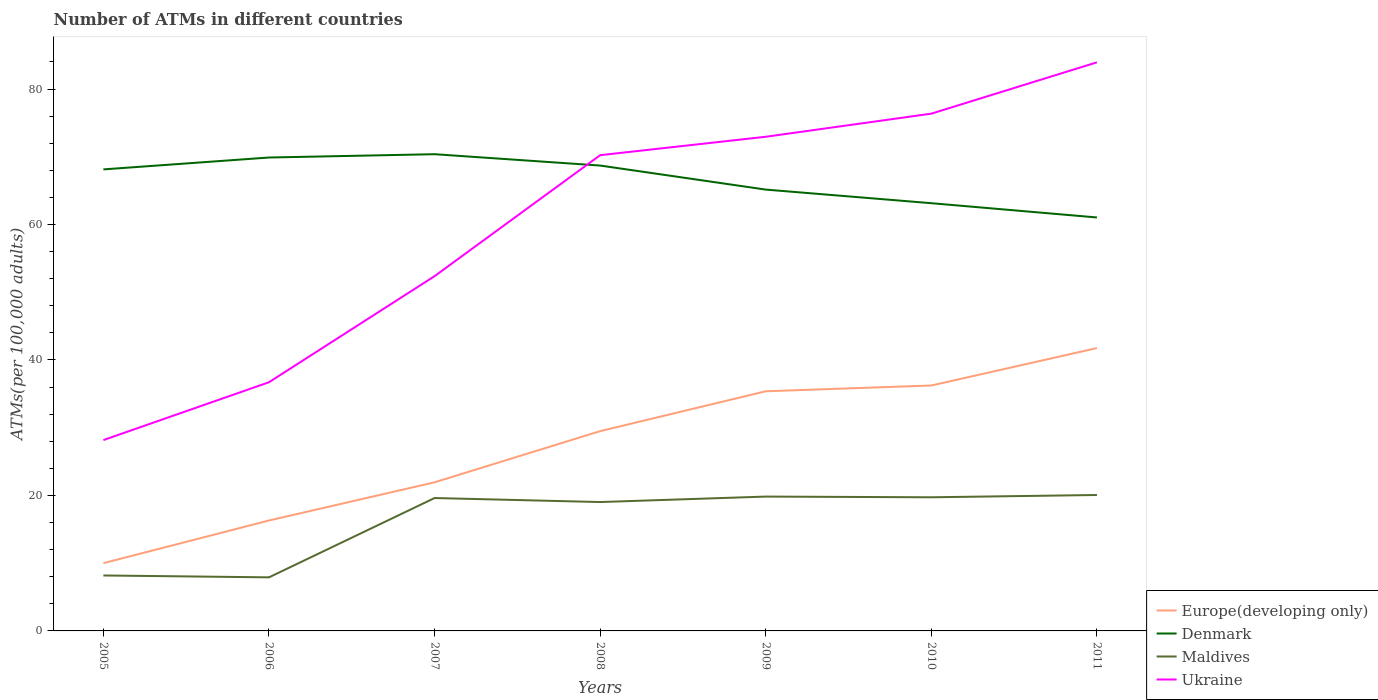Across all years, what is the maximum number of ATMs in Ukraine?
Give a very brief answer. 28.17. In which year was the number of ATMs in Europe(developing only) maximum?
Offer a terse response. 2005. What is the total number of ATMs in Denmark in the graph?
Your response must be concise. -0.57. What is the difference between the highest and the second highest number of ATMs in Denmark?
Offer a very short reply. 9.34. Is the number of ATMs in Ukraine strictly greater than the number of ATMs in Europe(developing only) over the years?
Provide a succinct answer. No. How many years are there in the graph?
Offer a very short reply. 7. Are the values on the major ticks of Y-axis written in scientific E-notation?
Keep it short and to the point. No. Does the graph contain grids?
Provide a succinct answer. No. How many legend labels are there?
Provide a succinct answer. 4. What is the title of the graph?
Your answer should be very brief. Number of ATMs in different countries. What is the label or title of the X-axis?
Keep it short and to the point. Years. What is the label or title of the Y-axis?
Provide a succinct answer. ATMs(per 100,0 adults). What is the ATMs(per 100,000 adults) of Europe(developing only) in 2005?
Ensure brevity in your answer.  10. What is the ATMs(per 100,000 adults) in Denmark in 2005?
Offer a terse response. 68.14. What is the ATMs(per 100,000 adults) of Maldives in 2005?
Offer a very short reply. 8.19. What is the ATMs(per 100,000 adults) of Ukraine in 2005?
Give a very brief answer. 28.17. What is the ATMs(per 100,000 adults) of Europe(developing only) in 2006?
Your answer should be very brief. 16.3. What is the ATMs(per 100,000 adults) in Denmark in 2006?
Offer a terse response. 69.89. What is the ATMs(per 100,000 adults) of Maldives in 2006?
Your response must be concise. 7.91. What is the ATMs(per 100,000 adults) of Ukraine in 2006?
Offer a terse response. 36.72. What is the ATMs(per 100,000 adults) in Europe(developing only) in 2007?
Provide a succinct answer. 21.94. What is the ATMs(per 100,000 adults) of Denmark in 2007?
Your response must be concise. 70.38. What is the ATMs(per 100,000 adults) in Maldives in 2007?
Make the answer very short. 19.62. What is the ATMs(per 100,000 adults) of Ukraine in 2007?
Ensure brevity in your answer.  52.38. What is the ATMs(per 100,000 adults) in Europe(developing only) in 2008?
Provide a succinct answer. 29.5. What is the ATMs(per 100,000 adults) of Denmark in 2008?
Offer a terse response. 68.71. What is the ATMs(per 100,000 adults) of Maldives in 2008?
Keep it short and to the point. 19.03. What is the ATMs(per 100,000 adults) in Ukraine in 2008?
Keep it short and to the point. 70.24. What is the ATMs(per 100,000 adults) of Europe(developing only) in 2009?
Make the answer very short. 35.38. What is the ATMs(per 100,000 adults) of Denmark in 2009?
Keep it short and to the point. 65.16. What is the ATMs(per 100,000 adults) of Maldives in 2009?
Your response must be concise. 19.83. What is the ATMs(per 100,000 adults) of Ukraine in 2009?
Ensure brevity in your answer.  72.96. What is the ATMs(per 100,000 adults) in Europe(developing only) in 2010?
Provide a short and direct response. 36.23. What is the ATMs(per 100,000 adults) of Denmark in 2010?
Your answer should be compact. 63.15. What is the ATMs(per 100,000 adults) of Maldives in 2010?
Provide a succinct answer. 19.73. What is the ATMs(per 100,000 adults) in Ukraine in 2010?
Provide a short and direct response. 76.37. What is the ATMs(per 100,000 adults) of Europe(developing only) in 2011?
Offer a very short reply. 41.76. What is the ATMs(per 100,000 adults) in Denmark in 2011?
Ensure brevity in your answer.  61.04. What is the ATMs(per 100,000 adults) in Maldives in 2011?
Make the answer very short. 20.07. What is the ATMs(per 100,000 adults) in Ukraine in 2011?
Give a very brief answer. 83.95. Across all years, what is the maximum ATMs(per 100,000 adults) of Europe(developing only)?
Offer a very short reply. 41.76. Across all years, what is the maximum ATMs(per 100,000 adults) of Denmark?
Provide a short and direct response. 70.38. Across all years, what is the maximum ATMs(per 100,000 adults) in Maldives?
Provide a succinct answer. 20.07. Across all years, what is the maximum ATMs(per 100,000 adults) in Ukraine?
Ensure brevity in your answer.  83.95. Across all years, what is the minimum ATMs(per 100,000 adults) of Europe(developing only)?
Make the answer very short. 10. Across all years, what is the minimum ATMs(per 100,000 adults) of Denmark?
Make the answer very short. 61.04. Across all years, what is the minimum ATMs(per 100,000 adults) of Maldives?
Make the answer very short. 7.91. Across all years, what is the minimum ATMs(per 100,000 adults) of Ukraine?
Make the answer very short. 28.17. What is the total ATMs(per 100,000 adults) of Europe(developing only) in the graph?
Your answer should be compact. 191.12. What is the total ATMs(per 100,000 adults) in Denmark in the graph?
Your answer should be very brief. 466.47. What is the total ATMs(per 100,000 adults) of Maldives in the graph?
Ensure brevity in your answer.  114.38. What is the total ATMs(per 100,000 adults) in Ukraine in the graph?
Keep it short and to the point. 420.78. What is the difference between the ATMs(per 100,000 adults) of Europe(developing only) in 2005 and that in 2006?
Ensure brevity in your answer.  -6.3. What is the difference between the ATMs(per 100,000 adults) of Denmark in 2005 and that in 2006?
Your answer should be compact. -1.75. What is the difference between the ATMs(per 100,000 adults) in Maldives in 2005 and that in 2006?
Your answer should be very brief. 0.28. What is the difference between the ATMs(per 100,000 adults) in Ukraine in 2005 and that in 2006?
Give a very brief answer. -8.54. What is the difference between the ATMs(per 100,000 adults) in Europe(developing only) in 2005 and that in 2007?
Provide a short and direct response. -11.94. What is the difference between the ATMs(per 100,000 adults) in Denmark in 2005 and that in 2007?
Ensure brevity in your answer.  -2.24. What is the difference between the ATMs(per 100,000 adults) of Maldives in 2005 and that in 2007?
Offer a very short reply. -11.43. What is the difference between the ATMs(per 100,000 adults) in Ukraine in 2005 and that in 2007?
Keep it short and to the point. -24.2. What is the difference between the ATMs(per 100,000 adults) of Europe(developing only) in 2005 and that in 2008?
Your answer should be very brief. -19.49. What is the difference between the ATMs(per 100,000 adults) of Denmark in 2005 and that in 2008?
Your answer should be compact. -0.57. What is the difference between the ATMs(per 100,000 adults) in Maldives in 2005 and that in 2008?
Provide a succinct answer. -10.84. What is the difference between the ATMs(per 100,000 adults) in Ukraine in 2005 and that in 2008?
Offer a very short reply. -42.06. What is the difference between the ATMs(per 100,000 adults) of Europe(developing only) in 2005 and that in 2009?
Ensure brevity in your answer.  -25.38. What is the difference between the ATMs(per 100,000 adults) of Denmark in 2005 and that in 2009?
Offer a terse response. 2.98. What is the difference between the ATMs(per 100,000 adults) of Maldives in 2005 and that in 2009?
Your answer should be compact. -11.65. What is the difference between the ATMs(per 100,000 adults) in Ukraine in 2005 and that in 2009?
Provide a succinct answer. -44.78. What is the difference between the ATMs(per 100,000 adults) in Europe(developing only) in 2005 and that in 2010?
Offer a terse response. -26.23. What is the difference between the ATMs(per 100,000 adults) in Denmark in 2005 and that in 2010?
Your answer should be very brief. 4.99. What is the difference between the ATMs(per 100,000 adults) of Maldives in 2005 and that in 2010?
Your response must be concise. -11.54. What is the difference between the ATMs(per 100,000 adults) of Ukraine in 2005 and that in 2010?
Your answer should be very brief. -48.19. What is the difference between the ATMs(per 100,000 adults) in Europe(developing only) in 2005 and that in 2011?
Offer a terse response. -31.76. What is the difference between the ATMs(per 100,000 adults) of Denmark in 2005 and that in 2011?
Provide a short and direct response. 7.1. What is the difference between the ATMs(per 100,000 adults) in Maldives in 2005 and that in 2011?
Provide a succinct answer. -11.88. What is the difference between the ATMs(per 100,000 adults) of Ukraine in 2005 and that in 2011?
Ensure brevity in your answer.  -55.77. What is the difference between the ATMs(per 100,000 adults) of Europe(developing only) in 2006 and that in 2007?
Keep it short and to the point. -5.64. What is the difference between the ATMs(per 100,000 adults) in Denmark in 2006 and that in 2007?
Provide a succinct answer. -0.49. What is the difference between the ATMs(per 100,000 adults) of Maldives in 2006 and that in 2007?
Your answer should be compact. -11.71. What is the difference between the ATMs(per 100,000 adults) of Ukraine in 2006 and that in 2007?
Keep it short and to the point. -15.66. What is the difference between the ATMs(per 100,000 adults) of Europe(developing only) in 2006 and that in 2008?
Provide a short and direct response. -13.19. What is the difference between the ATMs(per 100,000 adults) of Denmark in 2006 and that in 2008?
Make the answer very short. 1.19. What is the difference between the ATMs(per 100,000 adults) of Maldives in 2006 and that in 2008?
Your answer should be very brief. -11.12. What is the difference between the ATMs(per 100,000 adults) of Ukraine in 2006 and that in 2008?
Your response must be concise. -33.52. What is the difference between the ATMs(per 100,000 adults) of Europe(developing only) in 2006 and that in 2009?
Ensure brevity in your answer.  -19.08. What is the difference between the ATMs(per 100,000 adults) in Denmark in 2006 and that in 2009?
Your answer should be compact. 4.74. What is the difference between the ATMs(per 100,000 adults) in Maldives in 2006 and that in 2009?
Give a very brief answer. -11.93. What is the difference between the ATMs(per 100,000 adults) of Ukraine in 2006 and that in 2009?
Provide a short and direct response. -36.24. What is the difference between the ATMs(per 100,000 adults) in Europe(developing only) in 2006 and that in 2010?
Provide a short and direct response. -19.93. What is the difference between the ATMs(per 100,000 adults) of Denmark in 2006 and that in 2010?
Give a very brief answer. 6.74. What is the difference between the ATMs(per 100,000 adults) of Maldives in 2006 and that in 2010?
Offer a terse response. -11.82. What is the difference between the ATMs(per 100,000 adults) in Ukraine in 2006 and that in 2010?
Provide a short and direct response. -39.65. What is the difference between the ATMs(per 100,000 adults) of Europe(developing only) in 2006 and that in 2011?
Ensure brevity in your answer.  -25.45. What is the difference between the ATMs(per 100,000 adults) of Denmark in 2006 and that in 2011?
Your answer should be very brief. 8.85. What is the difference between the ATMs(per 100,000 adults) of Maldives in 2006 and that in 2011?
Provide a succinct answer. -12.16. What is the difference between the ATMs(per 100,000 adults) of Ukraine in 2006 and that in 2011?
Your answer should be compact. -47.23. What is the difference between the ATMs(per 100,000 adults) of Europe(developing only) in 2007 and that in 2008?
Offer a very short reply. -7.55. What is the difference between the ATMs(per 100,000 adults) in Denmark in 2007 and that in 2008?
Offer a terse response. 1.68. What is the difference between the ATMs(per 100,000 adults) of Maldives in 2007 and that in 2008?
Make the answer very short. 0.59. What is the difference between the ATMs(per 100,000 adults) in Ukraine in 2007 and that in 2008?
Give a very brief answer. -17.86. What is the difference between the ATMs(per 100,000 adults) in Europe(developing only) in 2007 and that in 2009?
Provide a succinct answer. -13.44. What is the difference between the ATMs(per 100,000 adults) of Denmark in 2007 and that in 2009?
Your response must be concise. 5.23. What is the difference between the ATMs(per 100,000 adults) in Maldives in 2007 and that in 2009?
Your answer should be very brief. -0.22. What is the difference between the ATMs(per 100,000 adults) in Ukraine in 2007 and that in 2009?
Offer a terse response. -20.58. What is the difference between the ATMs(per 100,000 adults) in Europe(developing only) in 2007 and that in 2010?
Your response must be concise. -14.29. What is the difference between the ATMs(per 100,000 adults) of Denmark in 2007 and that in 2010?
Provide a short and direct response. 7.23. What is the difference between the ATMs(per 100,000 adults) of Maldives in 2007 and that in 2010?
Your response must be concise. -0.11. What is the difference between the ATMs(per 100,000 adults) in Ukraine in 2007 and that in 2010?
Your answer should be compact. -23.99. What is the difference between the ATMs(per 100,000 adults) of Europe(developing only) in 2007 and that in 2011?
Your response must be concise. -19.82. What is the difference between the ATMs(per 100,000 adults) of Denmark in 2007 and that in 2011?
Offer a terse response. 9.34. What is the difference between the ATMs(per 100,000 adults) in Maldives in 2007 and that in 2011?
Make the answer very short. -0.45. What is the difference between the ATMs(per 100,000 adults) in Ukraine in 2007 and that in 2011?
Your response must be concise. -31.57. What is the difference between the ATMs(per 100,000 adults) in Europe(developing only) in 2008 and that in 2009?
Offer a terse response. -5.88. What is the difference between the ATMs(per 100,000 adults) of Denmark in 2008 and that in 2009?
Give a very brief answer. 3.55. What is the difference between the ATMs(per 100,000 adults) of Maldives in 2008 and that in 2009?
Provide a succinct answer. -0.81. What is the difference between the ATMs(per 100,000 adults) in Ukraine in 2008 and that in 2009?
Provide a short and direct response. -2.72. What is the difference between the ATMs(per 100,000 adults) of Europe(developing only) in 2008 and that in 2010?
Provide a short and direct response. -6.74. What is the difference between the ATMs(per 100,000 adults) of Denmark in 2008 and that in 2010?
Your answer should be compact. 5.56. What is the difference between the ATMs(per 100,000 adults) in Maldives in 2008 and that in 2010?
Offer a terse response. -0.7. What is the difference between the ATMs(per 100,000 adults) in Ukraine in 2008 and that in 2010?
Offer a very short reply. -6.13. What is the difference between the ATMs(per 100,000 adults) in Europe(developing only) in 2008 and that in 2011?
Provide a short and direct response. -12.26. What is the difference between the ATMs(per 100,000 adults) in Denmark in 2008 and that in 2011?
Make the answer very short. 7.66. What is the difference between the ATMs(per 100,000 adults) of Maldives in 2008 and that in 2011?
Provide a short and direct response. -1.04. What is the difference between the ATMs(per 100,000 adults) of Ukraine in 2008 and that in 2011?
Keep it short and to the point. -13.71. What is the difference between the ATMs(per 100,000 adults) in Europe(developing only) in 2009 and that in 2010?
Give a very brief answer. -0.85. What is the difference between the ATMs(per 100,000 adults) in Denmark in 2009 and that in 2010?
Offer a very short reply. 2.01. What is the difference between the ATMs(per 100,000 adults) in Maldives in 2009 and that in 2010?
Your response must be concise. 0.1. What is the difference between the ATMs(per 100,000 adults) of Ukraine in 2009 and that in 2010?
Ensure brevity in your answer.  -3.41. What is the difference between the ATMs(per 100,000 adults) of Europe(developing only) in 2009 and that in 2011?
Ensure brevity in your answer.  -6.38. What is the difference between the ATMs(per 100,000 adults) of Denmark in 2009 and that in 2011?
Keep it short and to the point. 4.11. What is the difference between the ATMs(per 100,000 adults) of Maldives in 2009 and that in 2011?
Ensure brevity in your answer.  -0.23. What is the difference between the ATMs(per 100,000 adults) of Ukraine in 2009 and that in 2011?
Your answer should be compact. -10.99. What is the difference between the ATMs(per 100,000 adults) of Europe(developing only) in 2010 and that in 2011?
Provide a succinct answer. -5.52. What is the difference between the ATMs(per 100,000 adults) of Denmark in 2010 and that in 2011?
Offer a terse response. 2.11. What is the difference between the ATMs(per 100,000 adults) of Maldives in 2010 and that in 2011?
Provide a succinct answer. -0.34. What is the difference between the ATMs(per 100,000 adults) in Ukraine in 2010 and that in 2011?
Ensure brevity in your answer.  -7.58. What is the difference between the ATMs(per 100,000 adults) in Europe(developing only) in 2005 and the ATMs(per 100,000 adults) in Denmark in 2006?
Give a very brief answer. -59.89. What is the difference between the ATMs(per 100,000 adults) of Europe(developing only) in 2005 and the ATMs(per 100,000 adults) of Maldives in 2006?
Give a very brief answer. 2.09. What is the difference between the ATMs(per 100,000 adults) in Europe(developing only) in 2005 and the ATMs(per 100,000 adults) in Ukraine in 2006?
Give a very brief answer. -26.71. What is the difference between the ATMs(per 100,000 adults) of Denmark in 2005 and the ATMs(per 100,000 adults) of Maldives in 2006?
Your answer should be very brief. 60.23. What is the difference between the ATMs(per 100,000 adults) in Denmark in 2005 and the ATMs(per 100,000 adults) in Ukraine in 2006?
Ensure brevity in your answer.  31.42. What is the difference between the ATMs(per 100,000 adults) of Maldives in 2005 and the ATMs(per 100,000 adults) of Ukraine in 2006?
Make the answer very short. -28.53. What is the difference between the ATMs(per 100,000 adults) of Europe(developing only) in 2005 and the ATMs(per 100,000 adults) of Denmark in 2007?
Give a very brief answer. -60.38. What is the difference between the ATMs(per 100,000 adults) in Europe(developing only) in 2005 and the ATMs(per 100,000 adults) in Maldives in 2007?
Keep it short and to the point. -9.62. What is the difference between the ATMs(per 100,000 adults) of Europe(developing only) in 2005 and the ATMs(per 100,000 adults) of Ukraine in 2007?
Give a very brief answer. -42.38. What is the difference between the ATMs(per 100,000 adults) of Denmark in 2005 and the ATMs(per 100,000 adults) of Maldives in 2007?
Your answer should be very brief. 48.52. What is the difference between the ATMs(per 100,000 adults) in Denmark in 2005 and the ATMs(per 100,000 adults) in Ukraine in 2007?
Your answer should be compact. 15.76. What is the difference between the ATMs(per 100,000 adults) in Maldives in 2005 and the ATMs(per 100,000 adults) in Ukraine in 2007?
Your answer should be compact. -44.19. What is the difference between the ATMs(per 100,000 adults) in Europe(developing only) in 2005 and the ATMs(per 100,000 adults) in Denmark in 2008?
Keep it short and to the point. -58.7. What is the difference between the ATMs(per 100,000 adults) of Europe(developing only) in 2005 and the ATMs(per 100,000 adults) of Maldives in 2008?
Your answer should be very brief. -9.03. What is the difference between the ATMs(per 100,000 adults) of Europe(developing only) in 2005 and the ATMs(per 100,000 adults) of Ukraine in 2008?
Provide a short and direct response. -60.24. What is the difference between the ATMs(per 100,000 adults) in Denmark in 2005 and the ATMs(per 100,000 adults) in Maldives in 2008?
Provide a short and direct response. 49.11. What is the difference between the ATMs(per 100,000 adults) of Denmark in 2005 and the ATMs(per 100,000 adults) of Ukraine in 2008?
Your answer should be compact. -2.1. What is the difference between the ATMs(per 100,000 adults) in Maldives in 2005 and the ATMs(per 100,000 adults) in Ukraine in 2008?
Provide a short and direct response. -62.05. What is the difference between the ATMs(per 100,000 adults) in Europe(developing only) in 2005 and the ATMs(per 100,000 adults) in Denmark in 2009?
Your answer should be very brief. -55.15. What is the difference between the ATMs(per 100,000 adults) of Europe(developing only) in 2005 and the ATMs(per 100,000 adults) of Maldives in 2009?
Your response must be concise. -9.83. What is the difference between the ATMs(per 100,000 adults) in Europe(developing only) in 2005 and the ATMs(per 100,000 adults) in Ukraine in 2009?
Make the answer very short. -62.95. What is the difference between the ATMs(per 100,000 adults) in Denmark in 2005 and the ATMs(per 100,000 adults) in Maldives in 2009?
Provide a short and direct response. 48.31. What is the difference between the ATMs(per 100,000 adults) in Denmark in 2005 and the ATMs(per 100,000 adults) in Ukraine in 2009?
Your answer should be compact. -4.82. What is the difference between the ATMs(per 100,000 adults) of Maldives in 2005 and the ATMs(per 100,000 adults) of Ukraine in 2009?
Make the answer very short. -64.77. What is the difference between the ATMs(per 100,000 adults) in Europe(developing only) in 2005 and the ATMs(per 100,000 adults) in Denmark in 2010?
Your response must be concise. -53.15. What is the difference between the ATMs(per 100,000 adults) in Europe(developing only) in 2005 and the ATMs(per 100,000 adults) in Maldives in 2010?
Make the answer very short. -9.73. What is the difference between the ATMs(per 100,000 adults) of Europe(developing only) in 2005 and the ATMs(per 100,000 adults) of Ukraine in 2010?
Provide a short and direct response. -66.37. What is the difference between the ATMs(per 100,000 adults) of Denmark in 2005 and the ATMs(per 100,000 adults) of Maldives in 2010?
Give a very brief answer. 48.41. What is the difference between the ATMs(per 100,000 adults) of Denmark in 2005 and the ATMs(per 100,000 adults) of Ukraine in 2010?
Make the answer very short. -8.23. What is the difference between the ATMs(per 100,000 adults) of Maldives in 2005 and the ATMs(per 100,000 adults) of Ukraine in 2010?
Give a very brief answer. -68.18. What is the difference between the ATMs(per 100,000 adults) in Europe(developing only) in 2005 and the ATMs(per 100,000 adults) in Denmark in 2011?
Your answer should be very brief. -51.04. What is the difference between the ATMs(per 100,000 adults) in Europe(developing only) in 2005 and the ATMs(per 100,000 adults) in Maldives in 2011?
Ensure brevity in your answer.  -10.07. What is the difference between the ATMs(per 100,000 adults) of Europe(developing only) in 2005 and the ATMs(per 100,000 adults) of Ukraine in 2011?
Make the answer very short. -73.94. What is the difference between the ATMs(per 100,000 adults) in Denmark in 2005 and the ATMs(per 100,000 adults) in Maldives in 2011?
Give a very brief answer. 48.07. What is the difference between the ATMs(per 100,000 adults) in Denmark in 2005 and the ATMs(per 100,000 adults) in Ukraine in 2011?
Provide a succinct answer. -15.81. What is the difference between the ATMs(per 100,000 adults) of Maldives in 2005 and the ATMs(per 100,000 adults) of Ukraine in 2011?
Give a very brief answer. -75.76. What is the difference between the ATMs(per 100,000 adults) in Europe(developing only) in 2006 and the ATMs(per 100,000 adults) in Denmark in 2007?
Provide a short and direct response. -54.08. What is the difference between the ATMs(per 100,000 adults) of Europe(developing only) in 2006 and the ATMs(per 100,000 adults) of Maldives in 2007?
Your response must be concise. -3.31. What is the difference between the ATMs(per 100,000 adults) in Europe(developing only) in 2006 and the ATMs(per 100,000 adults) in Ukraine in 2007?
Offer a terse response. -36.07. What is the difference between the ATMs(per 100,000 adults) of Denmark in 2006 and the ATMs(per 100,000 adults) of Maldives in 2007?
Your response must be concise. 50.27. What is the difference between the ATMs(per 100,000 adults) in Denmark in 2006 and the ATMs(per 100,000 adults) in Ukraine in 2007?
Provide a succinct answer. 17.52. What is the difference between the ATMs(per 100,000 adults) in Maldives in 2006 and the ATMs(per 100,000 adults) in Ukraine in 2007?
Give a very brief answer. -44.47. What is the difference between the ATMs(per 100,000 adults) of Europe(developing only) in 2006 and the ATMs(per 100,000 adults) of Denmark in 2008?
Make the answer very short. -52.4. What is the difference between the ATMs(per 100,000 adults) of Europe(developing only) in 2006 and the ATMs(per 100,000 adults) of Maldives in 2008?
Your answer should be very brief. -2.72. What is the difference between the ATMs(per 100,000 adults) in Europe(developing only) in 2006 and the ATMs(per 100,000 adults) in Ukraine in 2008?
Give a very brief answer. -53.93. What is the difference between the ATMs(per 100,000 adults) in Denmark in 2006 and the ATMs(per 100,000 adults) in Maldives in 2008?
Offer a very short reply. 50.87. What is the difference between the ATMs(per 100,000 adults) of Denmark in 2006 and the ATMs(per 100,000 adults) of Ukraine in 2008?
Provide a succinct answer. -0.34. What is the difference between the ATMs(per 100,000 adults) in Maldives in 2006 and the ATMs(per 100,000 adults) in Ukraine in 2008?
Offer a very short reply. -62.33. What is the difference between the ATMs(per 100,000 adults) in Europe(developing only) in 2006 and the ATMs(per 100,000 adults) in Denmark in 2009?
Offer a terse response. -48.85. What is the difference between the ATMs(per 100,000 adults) of Europe(developing only) in 2006 and the ATMs(per 100,000 adults) of Maldives in 2009?
Provide a succinct answer. -3.53. What is the difference between the ATMs(per 100,000 adults) in Europe(developing only) in 2006 and the ATMs(per 100,000 adults) in Ukraine in 2009?
Provide a succinct answer. -56.65. What is the difference between the ATMs(per 100,000 adults) in Denmark in 2006 and the ATMs(per 100,000 adults) in Maldives in 2009?
Make the answer very short. 50.06. What is the difference between the ATMs(per 100,000 adults) of Denmark in 2006 and the ATMs(per 100,000 adults) of Ukraine in 2009?
Offer a terse response. -3.06. What is the difference between the ATMs(per 100,000 adults) in Maldives in 2006 and the ATMs(per 100,000 adults) in Ukraine in 2009?
Provide a succinct answer. -65.05. What is the difference between the ATMs(per 100,000 adults) in Europe(developing only) in 2006 and the ATMs(per 100,000 adults) in Denmark in 2010?
Provide a short and direct response. -46.84. What is the difference between the ATMs(per 100,000 adults) in Europe(developing only) in 2006 and the ATMs(per 100,000 adults) in Maldives in 2010?
Offer a terse response. -3.43. What is the difference between the ATMs(per 100,000 adults) of Europe(developing only) in 2006 and the ATMs(per 100,000 adults) of Ukraine in 2010?
Provide a succinct answer. -60.06. What is the difference between the ATMs(per 100,000 adults) of Denmark in 2006 and the ATMs(per 100,000 adults) of Maldives in 2010?
Offer a terse response. 50.16. What is the difference between the ATMs(per 100,000 adults) in Denmark in 2006 and the ATMs(per 100,000 adults) in Ukraine in 2010?
Your answer should be compact. -6.48. What is the difference between the ATMs(per 100,000 adults) of Maldives in 2006 and the ATMs(per 100,000 adults) of Ukraine in 2010?
Your answer should be compact. -68.46. What is the difference between the ATMs(per 100,000 adults) of Europe(developing only) in 2006 and the ATMs(per 100,000 adults) of Denmark in 2011?
Ensure brevity in your answer.  -44.74. What is the difference between the ATMs(per 100,000 adults) of Europe(developing only) in 2006 and the ATMs(per 100,000 adults) of Maldives in 2011?
Keep it short and to the point. -3.76. What is the difference between the ATMs(per 100,000 adults) of Europe(developing only) in 2006 and the ATMs(per 100,000 adults) of Ukraine in 2011?
Provide a short and direct response. -67.64. What is the difference between the ATMs(per 100,000 adults) of Denmark in 2006 and the ATMs(per 100,000 adults) of Maldives in 2011?
Provide a succinct answer. 49.82. What is the difference between the ATMs(per 100,000 adults) of Denmark in 2006 and the ATMs(per 100,000 adults) of Ukraine in 2011?
Your response must be concise. -14.05. What is the difference between the ATMs(per 100,000 adults) in Maldives in 2006 and the ATMs(per 100,000 adults) in Ukraine in 2011?
Give a very brief answer. -76.04. What is the difference between the ATMs(per 100,000 adults) in Europe(developing only) in 2007 and the ATMs(per 100,000 adults) in Denmark in 2008?
Provide a succinct answer. -46.76. What is the difference between the ATMs(per 100,000 adults) of Europe(developing only) in 2007 and the ATMs(per 100,000 adults) of Maldives in 2008?
Keep it short and to the point. 2.91. What is the difference between the ATMs(per 100,000 adults) in Europe(developing only) in 2007 and the ATMs(per 100,000 adults) in Ukraine in 2008?
Offer a very short reply. -48.3. What is the difference between the ATMs(per 100,000 adults) of Denmark in 2007 and the ATMs(per 100,000 adults) of Maldives in 2008?
Your answer should be compact. 51.35. What is the difference between the ATMs(per 100,000 adults) in Denmark in 2007 and the ATMs(per 100,000 adults) in Ukraine in 2008?
Make the answer very short. 0.14. What is the difference between the ATMs(per 100,000 adults) in Maldives in 2007 and the ATMs(per 100,000 adults) in Ukraine in 2008?
Your answer should be compact. -50.62. What is the difference between the ATMs(per 100,000 adults) in Europe(developing only) in 2007 and the ATMs(per 100,000 adults) in Denmark in 2009?
Your answer should be very brief. -43.22. What is the difference between the ATMs(per 100,000 adults) of Europe(developing only) in 2007 and the ATMs(per 100,000 adults) of Maldives in 2009?
Your response must be concise. 2.11. What is the difference between the ATMs(per 100,000 adults) in Europe(developing only) in 2007 and the ATMs(per 100,000 adults) in Ukraine in 2009?
Make the answer very short. -51.01. What is the difference between the ATMs(per 100,000 adults) in Denmark in 2007 and the ATMs(per 100,000 adults) in Maldives in 2009?
Offer a terse response. 50.55. What is the difference between the ATMs(per 100,000 adults) in Denmark in 2007 and the ATMs(per 100,000 adults) in Ukraine in 2009?
Ensure brevity in your answer.  -2.57. What is the difference between the ATMs(per 100,000 adults) in Maldives in 2007 and the ATMs(per 100,000 adults) in Ukraine in 2009?
Your answer should be compact. -53.34. What is the difference between the ATMs(per 100,000 adults) in Europe(developing only) in 2007 and the ATMs(per 100,000 adults) in Denmark in 2010?
Offer a terse response. -41.21. What is the difference between the ATMs(per 100,000 adults) in Europe(developing only) in 2007 and the ATMs(per 100,000 adults) in Maldives in 2010?
Your answer should be very brief. 2.21. What is the difference between the ATMs(per 100,000 adults) in Europe(developing only) in 2007 and the ATMs(per 100,000 adults) in Ukraine in 2010?
Your answer should be compact. -54.43. What is the difference between the ATMs(per 100,000 adults) in Denmark in 2007 and the ATMs(per 100,000 adults) in Maldives in 2010?
Your answer should be very brief. 50.65. What is the difference between the ATMs(per 100,000 adults) of Denmark in 2007 and the ATMs(per 100,000 adults) of Ukraine in 2010?
Your answer should be very brief. -5.99. What is the difference between the ATMs(per 100,000 adults) of Maldives in 2007 and the ATMs(per 100,000 adults) of Ukraine in 2010?
Provide a short and direct response. -56.75. What is the difference between the ATMs(per 100,000 adults) of Europe(developing only) in 2007 and the ATMs(per 100,000 adults) of Denmark in 2011?
Give a very brief answer. -39.1. What is the difference between the ATMs(per 100,000 adults) in Europe(developing only) in 2007 and the ATMs(per 100,000 adults) in Maldives in 2011?
Your answer should be very brief. 1.87. What is the difference between the ATMs(per 100,000 adults) in Europe(developing only) in 2007 and the ATMs(per 100,000 adults) in Ukraine in 2011?
Provide a succinct answer. -62. What is the difference between the ATMs(per 100,000 adults) of Denmark in 2007 and the ATMs(per 100,000 adults) of Maldives in 2011?
Offer a very short reply. 50.31. What is the difference between the ATMs(per 100,000 adults) in Denmark in 2007 and the ATMs(per 100,000 adults) in Ukraine in 2011?
Offer a terse response. -13.56. What is the difference between the ATMs(per 100,000 adults) of Maldives in 2007 and the ATMs(per 100,000 adults) of Ukraine in 2011?
Keep it short and to the point. -64.33. What is the difference between the ATMs(per 100,000 adults) in Europe(developing only) in 2008 and the ATMs(per 100,000 adults) in Denmark in 2009?
Provide a succinct answer. -35.66. What is the difference between the ATMs(per 100,000 adults) of Europe(developing only) in 2008 and the ATMs(per 100,000 adults) of Maldives in 2009?
Give a very brief answer. 9.66. What is the difference between the ATMs(per 100,000 adults) in Europe(developing only) in 2008 and the ATMs(per 100,000 adults) in Ukraine in 2009?
Offer a terse response. -43.46. What is the difference between the ATMs(per 100,000 adults) in Denmark in 2008 and the ATMs(per 100,000 adults) in Maldives in 2009?
Ensure brevity in your answer.  48.87. What is the difference between the ATMs(per 100,000 adults) of Denmark in 2008 and the ATMs(per 100,000 adults) of Ukraine in 2009?
Provide a short and direct response. -4.25. What is the difference between the ATMs(per 100,000 adults) in Maldives in 2008 and the ATMs(per 100,000 adults) in Ukraine in 2009?
Offer a terse response. -53.93. What is the difference between the ATMs(per 100,000 adults) in Europe(developing only) in 2008 and the ATMs(per 100,000 adults) in Denmark in 2010?
Provide a succinct answer. -33.65. What is the difference between the ATMs(per 100,000 adults) in Europe(developing only) in 2008 and the ATMs(per 100,000 adults) in Maldives in 2010?
Ensure brevity in your answer.  9.76. What is the difference between the ATMs(per 100,000 adults) in Europe(developing only) in 2008 and the ATMs(per 100,000 adults) in Ukraine in 2010?
Give a very brief answer. -46.87. What is the difference between the ATMs(per 100,000 adults) in Denmark in 2008 and the ATMs(per 100,000 adults) in Maldives in 2010?
Offer a very short reply. 48.97. What is the difference between the ATMs(per 100,000 adults) of Denmark in 2008 and the ATMs(per 100,000 adults) of Ukraine in 2010?
Your response must be concise. -7.66. What is the difference between the ATMs(per 100,000 adults) of Maldives in 2008 and the ATMs(per 100,000 adults) of Ukraine in 2010?
Provide a short and direct response. -57.34. What is the difference between the ATMs(per 100,000 adults) in Europe(developing only) in 2008 and the ATMs(per 100,000 adults) in Denmark in 2011?
Give a very brief answer. -31.55. What is the difference between the ATMs(per 100,000 adults) in Europe(developing only) in 2008 and the ATMs(per 100,000 adults) in Maldives in 2011?
Your response must be concise. 9.43. What is the difference between the ATMs(per 100,000 adults) of Europe(developing only) in 2008 and the ATMs(per 100,000 adults) of Ukraine in 2011?
Ensure brevity in your answer.  -54.45. What is the difference between the ATMs(per 100,000 adults) of Denmark in 2008 and the ATMs(per 100,000 adults) of Maldives in 2011?
Your answer should be compact. 48.64. What is the difference between the ATMs(per 100,000 adults) of Denmark in 2008 and the ATMs(per 100,000 adults) of Ukraine in 2011?
Your answer should be very brief. -15.24. What is the difference between the ATMs(per 100,000 adults) in Maldives in 2008 and the ATMs(per 100,000 adults) in Ukraine in 2011?
Your answer should be very brief. -64.92. What is the difference between the ATMs(per 100,000 adults) of Europe(developing only) in 2009 and the ATMs(per 100,000 adults) of Denmark in 2010?
Give a very brief answer. -27.77. What is the difference between the ATMs(per 100,000 adults) of Europe(developing only) in 2009 and the ATMs(per 100,000 adults) of Maldives in 2010?
Your response must be concise. 15.65. What is the difference between the ATMs(per 100,000 adults) of Europe(developing only) in 2009 and the ATMs(per 100,000 adults) of Ukraine in 2010?
Provide a short and direct response. -40.99. What is the difference between the ATMs(per 100,000 adults) of Denmark in 2009 and the ATMs(per 100,000 adults) of Maldives in 2010?
Keep it short and to the point. 45.43. What is the difference between the ATMs(per 100,000 adults) of Denmark in 2009 and the ATMs(per 100,000 adults) of Ukraine in 2010?
Your answer should be compact. -11.21. What is the difference between the ATMs(per 100,000 adults) in Maldives in 2009 and the ATMs(per 100,000 adults) in Ukraine in 2010?
Your answer should be very brief. -56.53. What is the difference between the ATMs(per 100,000 adults) of Europe(developing only) in 2009 and the ATMs(per 100,000 adults) of Denmark in 2011?
Offer a very short reply. -25.66. What is the difference between the ATMs(per 100,000 adults) of Europe(developing only) in 2009 and the ATMs(per 100,000 adults) of Maldives in 2011?
Make the answer very short. 15.31. What is the difference between the ATMs(per 100,000 adults) of Europe(developing only) in 2009 and the ATMs(per 100,000 adults) of Ukraine in 2011?
Make the answer very short. -48.57. What is the difference between the ATMs(per 100,000 adults) in Denmark in 2009 and the ATMs(per 100,000 adults) in Maldives in 2011?
Give a very brief answer. 45.09. What is the difference between the ATMs(per 100,000 adults) of Denmark in 2009 and the ATMs(per 100,000 adults) of Ukraine in 2011?
Your answer should be very brief. -18.79. What is the difference between the ATMs(per 100,000 adults) of Maldives in 2009 and the ATMs(per 100,000 adults) of Ukraine in 2011?
Ensure brevity in your answer.  -64.11. What is the difference between the ATMs(per 100,000 adults) in Europe(developing only) in 2010 and the ATMs(per 100,000 adults) in Denmark in 2011?
Your answer should be compact. -24.81. What is the difference between the ATMs(per 100,000 adults) of Europe(developing only) in 2010 and the ATMs(per 100,000 adults) of Maldives in 2011?
Provide a succinct answer. 16.16. What is the difference between the ATMs(per 100,000 adults) of Europe(developing only) in 2010 and the ATMs(per 100,000 adults) of Ukraine in 2011?
Your answer should be very brief. -47.71. What is the difference between the ATMs(per 100,000 adults) of Denmark in 2010 and the ATMs(per 100,000 adults) of Maldives in 2011?
Provide a succinct answer. 43.08. What is the difference between the ATMs(per 100,000 adults) of Denmark in 2010 and the ATMs(per 100,000 adults) of Ukraine in 2011?
Offer a terse response. -20.8. What is the difference between the ATMs(per 100,000 adults) of Maldives in 2010 and the ATMs(per 100,000 adults) of Ukraine in 2011?
Offer a terse response. -64.22. What is the average ATMs(per 100,000 adults) in Europe(developing only) per year?
Keep it short and to the point. 27.3. What is the average ATMs(per 100,000 adults) in Denmark per year?
Make the answer very short. 66.64. What is the average ATMs(per 100,000 adults) of Maldives per year?
Your response must be concise. 16.34. What is the average ATMs(per 100,000 adults) in Ukraine per year?
Keep it short and to the point. 60.11. In the year 2005, what is the difference between the ATMs(per 100,000 adults) of Europe(developing only) and ATMs(per 100,000 adults) of Denmark?
Make the answer very short. -58.14. In the year 2005, what is the difference between the ATMs(per 100,000 adults) in Europe(developing only) and ATMs(per 100,000 adults) in Maldives?
Ensure brevity in your answer.  1.81. In the year 2005, what is the difference between the ATMs(per 100,000 adults) of Europe(developing only) and ATMs(per 100,000 adults) of Ukraine?
Make the answer very short. -18.17. In the year 2005, what is the difference between the ATMs(per 100,000 adults) of Denmark and ATMs(per 100,000 adults) of Maldives?
Your answer should be compact. 59.95. In the year 2005, what is the difference between the ATMs(per 100,000 adults) of Denmark and ATMs(per 100,000 adults) of Ukraine?
Provide a short and direct response. 39.97. In the year 2005, what is the difference between the ATMs(per 100,000 adults) in Maldives and ATMs(per 100,000 adults) in Ukraine?
Provide a succinct answer. -19.99. In the year 2006, what is the difference between the ATMs(per 100,000 adults) of Europe(developing only) and ATMs(per 100,000 adults) of Denmark?
Offer a terse response. -53.59. In the year 2006, what is the difference between the ATMs(per 100,000 adults) in Europe(developing only) and ATMs(per 100,000 adults) in Maldives?
Provide a succinct answer. 8.4. In the year 2006, what is the difference between the ATMs(per 100,000 adults) of Europe(developing only) and ATMs(per 100,000 adults) of Ukraine?
Provide a succinct answer. -20.41. In the year 2006, what is the difference between the ATMs(per 100,000 adults) in Denmark and ATMs(per 100,000 adults) in Maldives?
Your answer should be compact. 61.98. In the year 2006, what is the difference between the ATMs(per 100,000 adults) in Denmark and ATMs(per 100,000 adults) in Ukraine?
Keep it short and to the point. 33.18. In the year 2006, what is the difference between the ATMs(per 100,000 adults) in Maldives and ATMs(per 100,000 adults) in Ukraine?
Offer a very short reply. -28.81. In the year 2007, what is the difference between the ATMs(per 100,000 adults) in Europe(developing only) and ATMs(per 100,000 adults) in Denmark?
Make the answer very short. -48.44. In the year 2007, what is the difference between the ATMs(per 100,000 adults) of Europe(developing only) and ATMs(per 100,000 adults) of Maldives?
Your answer should be very brief. 2.32. In the year 2007, what is the difference between the ATMs(per 100,000 adults) in Europe(developing only) and ATMs(per 100,000 adults) in Ukraine?
Offer a terse response. -30.44. In the year 2007, what is the difference between the ATMs(per 100,000 adults) in Denmark and ATMs(per 100,000 adults) in Maldives?
Provide a succinct answer. 50.76. In the year 2007, what is the difference between the ATMs(per 100,000 adults) of Denmark and ATMs(per 100,000 adults) of Ukraine?
Provide a short and direct response. 18.01. In the year 2007, what is the difference between the ATMs(per 100,000 adults) of Maldives and ATMs(per 100,000 adults) of Ukraine?
Your answer should be compact. -32.76. In the year 2008, what is the difference between the ATMs(per 100,000 adults) in Europe(developing only) and ATMs(per 100,000 adults) in Denmark?
Make the answer very short. -39.21. In the year 2008, what is the difference between the ATMs(per 100,000 adults) in Europe(developing only) and ATMs(per 100,000 adults) in Maldives?
Give a very brief answer. 10.47. In the year 2008, what is the difference between the ATMs(per 100,000 adults) of Europe(developing only) and ATMs(per 100,000 adults) of Ukraine?
Provide a short and direct response. -40.74. In the year 2008, what is the difference between the ATMs(per 100,000 adults) of Denmark and ATMs(per 100,000 adults) of Maldives?
Your answer should be very brief. 49.68. In the year 2008, what is the difference between the ATMs(per 100,000 adults) in Denmark and ATMs(per 100,000 adults) in Ukraine?
Give a very brief answer. -1.53. In the year 2008, what is the difference between the ATMs(per 100,000 adults) of Maldives and ATMs(per 100,000 adults) of Ukraine?
Keep it short and to the point. -51.21. In the year 2009, what is the difference between the ATMs(per 100,000 adults) in Europe(developing only) and ATMs(per 100,000 adults) in Denmark?
Make the answer very short. -29.78. In the year 2009, what is the difference between the ATMs(per 100,000 adults) in Europe(developing only) and ATMs(per 100,000 adults) in Maldives?
Offer a very short reply. 15.55. In the year 2009, what is the difference between the ATMs(per 100,000 adults) in Europe(developing only) and ATMs(per 100,000 adults) in Ukraine?
Your answer should be compact. -37.58. In the year 2009, what is the difference between the ATMs(per 100,000 adults) of Denmark and ATMs(per 100,000 adults) of Maldives?
Provide a short and direct response. 45.32. In the year 2009, what is the difference between the ATMs(per 100,000 adults) of Denmark and ATMs(per 100,000 adults) of Ukraine?
Your answer should be very brief. -7.8. In the year 2009, what is the difference between the ATMs(per 100,000 adults) of Maldives and ATMs(per 100,000 adults) of Ukraine?
Your answer should be very brief. -53.12. In the year 2010, what is the difference between the ATMs(per 100,000 adults) in Europe(developing only) and ATMs(per 100,000 adults) in Denmark?
Your answer should be compact. -26.92. In the year 2010, what is the difference between the ATMs(per 100,000 adults) in Europe(developing only) and ATMs(per 100,000 adults) in Maldives?
Offer a terse response. 16.5. In the year 2010, what is the difference between the ATMs(per 100,000 adults) of Europe(developing only) and ATMs(per 100,000 adults) of Ukraine?
Provide a short and direct response. -40.14. In the year 2010, what is the difference between the ATMs(per 100,000 adults) of Denmark and ATMs(per 100,000 adults) of Maldives?
Ensure brevity in your answer.  43.42. In the year 2010, what is the difference between the ATMs(per 100,000 adults) in Denmark and ATMs(per 100,000 adults) in Ukraine?
Provide a short and direct response. -13.22. In the year 2010, what is the difference between the ATMs(per 100,000 adults) of Maldives and ATMs(per 100,000 adults) of Ukraine?
Provide a short and direct response. -56.64. In the year 2011, what is the difference between the ATMs(per 100,000 adults) of Europe(developing only) and ATMs(per 100,000 adults) of Denmark?
Keep it short and to the point. -19.28. In the year 2011, what is the difference between the ATMs(per 100,000 adults) of Europe(developing only) and ATMs(per 100,000 adults) of Maldives?
Provide a short and direct response. 21.69. In the year 2011, what is the difference between the ATMs(per 100,000 adults) of Europe(developing only) and ATMs(per 100,000 adults) of Ukraine?
Make the answer very short. -42.19. In the year 2011, what is the difference between the ATMs(per 100,000 adults) of Denmark and ATMs(per 100,000 adults) of Maldives?
Your answer should be very brief. 40.97. In the year 2011, what is the difference between the ATMs(per 100,000 adults) in Denmark and ATMs(per 100,000 adults) in Ukraine?
Offer a very short reply. -22.9. In the year 2011, what is the difference between the ATMs(per 100,000 adults) in Maldives and ATMs(per 100,000 adults) in Ukraine?
Make the answer very short. -63.88. What is the ratio of the ATMs(per 100,000 adults) in Europe(developing only) in 2005 to that in 2006?
Your answer should be compact. 0.61. What is the ratio of the ATMs(per 100,000 adults) in Denmark in 2005 to that in 2006?
Offer a very short reply. 0.97. What is the ratio of the ATMs(per 100,000 adults) in Maldives in 2005 to that in 2006?
Offer a terse response. 1.04. What is the ratio of the ATMs(per 100,000 adults) in Ukraine in 2005 to that in 2006?
Offer a terse response. 0.77. What is the ratio of the ATMs(per 100,000 adults) of Europe(developing only) in 2005 to that in 2007?
Provide a short and direct response. 0.46. What is the ratio of the ATMs(per 100,000 adults) in Denmark in 2005 to that in 2007?
Your answer should be very brief. 0.97. What is the ratio of the ATMs(per 100,000 adults) of Maldives in 2005 to that in 2007?
Keep it short and to the point. 0.42. What is the ratio of the ATMs(per 100,000 adults) of Ukraine in 2005 to that in 2007?
Make the answer very short. 0.54. What is the ratio of the ATMs(per 100,000 adults) of Europe(developing only) in 2005 to that in 2008?
Offer a very short reply. 0.34. What is the ratio of the ATMs(per 100,000 adults) of Denmark in 2005 to that in 2008?
Ensure brevity in your answer.  0.99. What is the ratio of the ATMs(per 100,000 adults) of Maldives in 2005 to that in 2008?
Offer a very short reply. 0.43. What is the ratio of the ATMs(per 100,000 adults) in Ukraine in 2005 to that in 2008?
Ensure brevity in your answer.  0.4. What is the ratio of the ATMs(per 100,000 adults) of Europe(developing only) in 2005 to that in 2009?
Make the answer very short. 0.28. What is the ratio of the ATMs(per 100,000 adults) in Denmark in 2005 to that in 2009?
Your answer should be very brief. 1.05. What is the ratio of the ATMs(per 100,000 adults) in Maldives in 2005 to that in 2009?
Your answer should be compact. 0.41. What is the ratio of the ATMs(per 100,000 adults) of Ukraine in 2005 to that in 2009?
Provide a short and direct response. 0.39. What is the ratio of the ATMs(per 100,000 adults) of Europe(developing only) in 2005 to that in 2010?
Your answer should be very brief. 0.28. What is the ratio of the ATMs(per 100,000 adults) in Denmark in 2005 to that in 2010?
Provide a succinct answer. 1.08. What is the ratio of the ATMs(per 100,000 adults) of Maldives in 2005 to that in 2010?
Ensure brevity in your answer.  0.41. What is the ratio of the ATMs(per 100,000 adults) in Ukraine in 2005 to that in 2010?
Give a very brief answer. 0.37. What is the ratio of the ATMs(per 100,000 adults) in Europe(developing only) in 2005 to that in 2011?
Provide a short and direct response. 0.24. What is the ratio of the ATMs(per 100,000 adults) of Denmark in 2005 to that in 2011?
Your response must be concise. 1.12. What is the ratio of the ATMs(per 100,000 adults) of Maldives in 2005 to that in 2011?
Keep it short and to the point. 0.41. What is the ratio of the ATMs(per 100,000 adults) of Ukraine in 2005 to that in 2011?
Make the answer very short. 0.34. What is the ratio of the ATMs(per 100,000 adults) of Europe(developing only) in 2006 to that in 2007?
Give a very brief answer. 0.74. What is the ratio of the ATMs(per 100,000 adults) of Denmark in 2006 to that in 2007?
Give a very brief answer. 0.99. What is the ratio of the ATMs(per 100,000 adults) of Maldives in 2006 to that in 2007?
Provide a succinct answer. 0.4. What is the ratio of the ATMs(per 100,000 adults) of Ukraine in 2006 to that in 2007?
Ensure brevity in your answer.  0.7. What is the ratio of the ATMs(per 100,000 adults) in Europe(developing only) in 2006 to that in 2008?
Give a very brief answer. 0.55. What is the ratio of the ATMs(per 100,000 adults) in Denmark in 2006 to that in 2008?
Give a very brief answer. 1.02. What is the ratio of the ATMs(per 100,000 adults) of Maldives in 2006 to that in 2008?
Provide a short and direct response. 0.42. What is the ratio of the ATMs(per 100,000 adults) in Ukraine in 2006 to that in 2008?
Offer a very short reply. 0.52. What is the ratio of the ATMs(per 100,000 adults) of Europe(developing only) in 2006 to that in 2009?
Your response must be concise. 0.46. What is the ratio of the ATMs(per 100,000 adults) of Denmark in 2006 to that in 2009?
Offer a terse response. 1.07. What is the ratio of the ATMs(per 100,000 adults) of Maldives in 2006 to that in 2009?
Your answer should be very brief. 0.4. What is the ratio of the ATMs(per 100,000 adults) of Ukraine in 2006 to that in 2009?
Keep it short and to the point. 0.5. What is the ratio of the ATMs(per 100,000 adults) in Europe(developing only) in 2006 to that in 2010?
Ensure brevity in your answer.  0.45. What is the ratio of the ATMs(per 100,000 adults) in Denmark in 2006 to that in 2010?
Your answer should be compact. 1.11. What is the ratio of the ATMs(per 100,000 adults) in Maldives in 2006 to that in 2010?
Offer a terse response. 0.4. What is the ratio of the ATMs(per 100,000 adults) of Ukraine in 2006 to that in 2010?
Your answer should be compact. 0.48. What is the ratio of the ATMs(per 100,000 adults) of Europe(developing only) in 2006 to that in 2011?
Make the answer very short. 0.39. What is the ratio of the ATMs(per 100,000 adults) of Denmark in 2006 to that in 2011?
Make the answer very short. 1.15. What is the ratio of the ATMs(per 100,000 adults) of Maldives in 2006 to that in 2011?
Offer a terse response. 0.39. What is the ratio of the ATMs(per 100,000 adults) of Ukraine in 2006 to that in 2011?
Keep it short and to the point. 0.44. What is the ratio of the ATMs(per 100,000 adults) in Europe(developing only) in 2007 to that in 2008?
Offer a terse response. 0.74. What is the ratio of the ATMs(per 100,000 adults) of Denmark in 2007 to that in 2008?
Provide a succinct answer. 1.02. What is the ratio of the ATMs(per 100,000 adults) of Maldives in 2007 to that in 2008?
Your answer should be compact. 1.03. What is the ratio of the ATMs(per 100,000 adults) in Ukraine in 2007 to that in 2008?
Ensure brevity in your answer.  0.75. What is the ratio of the ATMs(per 100,000 adults) in Europe(developing only) in 2007 to that in 2009?
Provide a succinct answer. 0.62. What is the ratio of the ATMs(per 100,000 adults) in Denmark in 2007 to that in 2009?
Your answer should be compact. 1.08. What is the ratio of the ATMs(per 100,000 adults) in Ukraine in 2007 to that in 2009?
Provide a succinct answer. 0.72. What is the ratio of the ATMs(per 100,000 adults) in Europe(developing only) in 2007 to that in 2010?
Ensure brevity in your answer.  0.61. What is the ratio of the ATMs(per 100,000 adults) of Denmark in 2007 to that in 2010?
Your response must be concise. 1.11. What is the ratio of the ATMs(per 100,000 adults) of Ukraine in 2007 to that in 2010?
Ensure brevity in your answer.  0.69. What is the ratio of the ATMs(per 100,000 adults) in Europe(developing only) in 2007 to that in 2011?
Offer a terse response. 0.53. What is the ratio of the ATMs(per 100,000 adults) of Denmark in 2007 to that in 2011?
Your response must be concise. 1.15. What is the ratio of the ATMs(per 100,000 adults) in Maldives in 2007 to that in 2011?
Provide a short and direct response. 0.98. What is the ratio of the ATMs(per 100,000 adults) in Ukraine in 2007 to that in 2011?
Ensure brevity in your answer.  0.62. What is the ratio of the ATMs(per 100,000 adults) in Europe(developing only) in 2008 to that in 2009?
Ensure brevity in your answer.  0.83. What is the ratio of the ATMs(per 100,000 adults) of Denmark in 2008 to that in 2009?
Provide a short and direct response. 1.05. What is the ratio of the ATMs(per 100,000 adults) in Maldives in 2008 to that in 2009?
Provide a short and direct response. 0.96. What is the ratio of the ATMs(per 100,000 adults) of Ukraine in 2008 to that in 2009?
Provide a short and direct response. 0.96. What is the ratio of the ATMs(per 100,000 adults) of Europe(developing only) in 2008 to that in 2010?
Your answer should be very brief. 0.81. What is the ratio of the ATMs(per 100,000 adults) of Denmark in 2008 to that in 2010?
Provide a short and direct response. 1.09. What is the ratio of the ATMs(per 100,000 adults) of Maldives in 2008 to that in 2010?
Give a very brief answer. 0.96. What is the ratio of the ATMs(per 100,000 adults) in Ukraine in 2008 to that in 2010?
Your response must be concise. 0.92. What is the ratio of the ATMs(per 100,000 adults) of Europe(developing only) in 2008 to that in 2011?
Make the answer very short. 0.71. What is the ratio of the ATMs(per 100,000 adults) of Denmark in 2008 to that in 2011?
Offer a very short reply. 1.13. What is the ratio of the ATMs(per 100,000 adults) in Maldives in 2008 to that in 2011?
Your answer should be very brief. 0.95. What is the ratio of the ATMs(per 100,000 adults) in Ukraine in 2008 to that in 2011?
Ensure brevity in your answer.  0.84. What is the ratio of the ATMs(per 100,000 adults) in Europe(developing only) in 2009 to that in 2010?
Your answer should be very brief. 0.98. What is the ratio of the ATMs(per 100,000 adults) of Denmark in 2009 to that in 2010?
Your answer should be compact. 1.03. What is the ratio of the ATMs(per 100,000 adults) of Maldives in 2009 to that in 2010?
Give a very brief answer. 1.01. What is the ratio of the ATMs(per 100,000 adults) of Ukraine in 2009 to that in 2010?
Your answer should be compact. 0.96. What is the ratio of the ATMs(per 100,000 adults) in Europe(developing only) in 2009 to that in 2011?
Make the answer very short. 0.85. What is the ratio of the ATMs(per 100,000 adults) of Denmark in 2009 to that in 2011?
Provide a succinct answer. 1.07. What is the ratio of the ATMs(per 100,000 adults) in Maldives in 2009 to that in 2011?
Provide a succinct answer. 0.99. What is the ratio of the ATMs(per 100,000 adults) of Ukraine in 2009 to that in 2011?
Ensure brevity in your answer.  0.87. What is the ratio of the ATMs(per 100,000 adults) of Europe(developing only) in 2010 to that in 2011?
Your answer should be compact. 0.87. What is the ratio of the ATMs(per 100,000 adults) in Denmark in 2010 to that in 2011?
Make the answer very short. 1.03. What is the ratio of the ATMs(per 100,000 adults) in Maldives in 2010 to that in 2011?
Your answer should be compact. 0.98. What is the ratio of the ATMs(per 100,000 adults) of Ukraine in 2010 to that in 2011?
Your answer should be compact. 0.91. What is the difference between the highest and the second highest ATMs(per 100,000 adults) of Europe(developing only)?
Your answer should be compact. 5.52. What is the difference between the highest and the second highest ATMs(per 100,000 adults) of Denmark?
Offer a very short reply. 0.49. What is the difference between the highest and the second highest ATMs(per 100,000 adults) of Maldives?
Provide a short and direct response. 0.23. What is the difference between the highest and the second highest ATMs(per 100,000 adults) of Ukraine?
Provide a succinct answer. 7.58. What is the difference between the highest and the lowest ATMs(per 100,000 adults) of Europe(developing only)?
Your answer should be compact. 31.76. What is the difference between the highest and the lowest ATMs(per 100,000 adults) in Denmark?
Offer a terse response. 9.34. What is the difference between the highest and the lowest ATMs(per 100,000 adults) in Maldives?
Your answer should be very brief. 12.16. What is the difference between the highest and the lowest ATMs(per 100,000 adults) in Ukraine?
Your answer should be very brief. 55.77. 